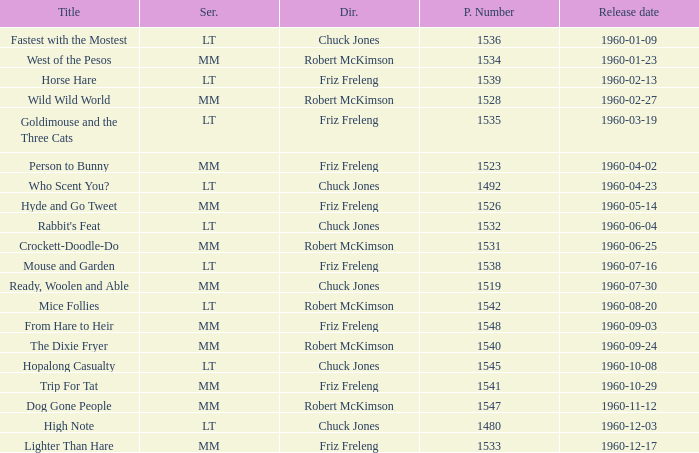What is the Series number of the episode with a production number of 1547? MM. 